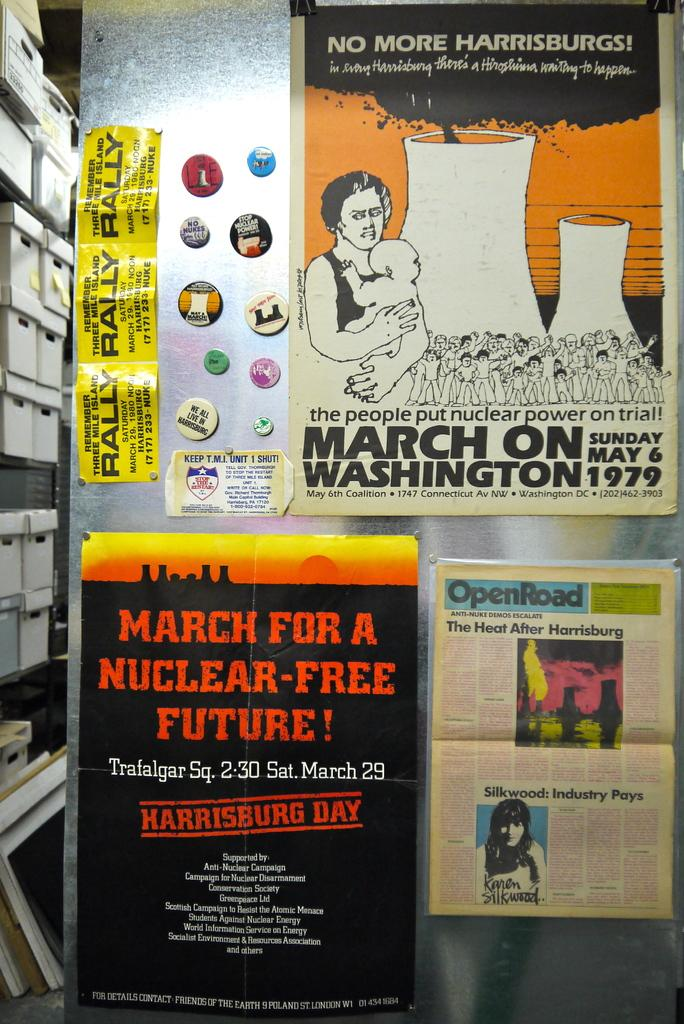What can be seen on the wall in the image? There are posts on the wall in the image. Where are the boxes located in the image? The boxes are on the side in a rack in the image. What shape is the popcorn in the image? There is no popcorn present in the image. How is the division of space represented in the image? The image does not depict any division of space; it only shows posts on the wall and boxes on the side in a rack. 